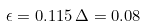Convert formula to latex. <formula><loc_0><loc_0><loc_500><loc_500>\epsilon = 0 . 1 1 5 \, \Delta = 0 . 0 8</formula> 